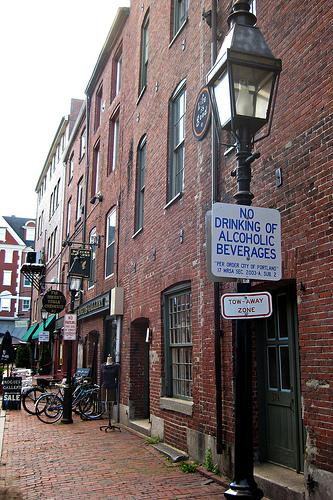Question: why are the lamps off?
Choices:
A. It is daytime.
B. They're broken.
C. It's time to sleep.
D. For effect.
Answer with the letter. Answer: A Question: what are the buildings made of?
Choices:
A. Stone.
B. Brick.
C. Steel.
D. Wood.
Answer with the letter. Answer: B Question: when was the photo taken?
Choices:
A. Night time.
B. Morning.
C. Dusk.
D. During the day.
Answer with the letter. Answer: D Question: what does the bottom sign say?
Choices:
A. Tow-away zone.
B. Stop.
C. No parking.
D. Open all day.
Answer with the letter. Answer: A Question: who is in the photo?
Choices:
A. No one.
B. 1 person.
C. Boys.
D. A man.
Answer with the letter. Answer: A Question: what does the top sign say?
Choices:
A. Parking for customers only.
B. Front entrance.
C. No drinking of alcoholic beverages.
D. Please park in rear.
Answer with the letter. Answer: C Question: where was the picture taken?
Choices:
A. Outdoors on a street.
B. Indoors in a house.
C. Indoors in a store.
D. Outdoors in a field.
Answer with the letter. Answer: A Question: how many lamp posts are shown?
Choices:
A. Two.
B. One.
C. Four.
D. Five.
Answer with the letter. Answer: A 